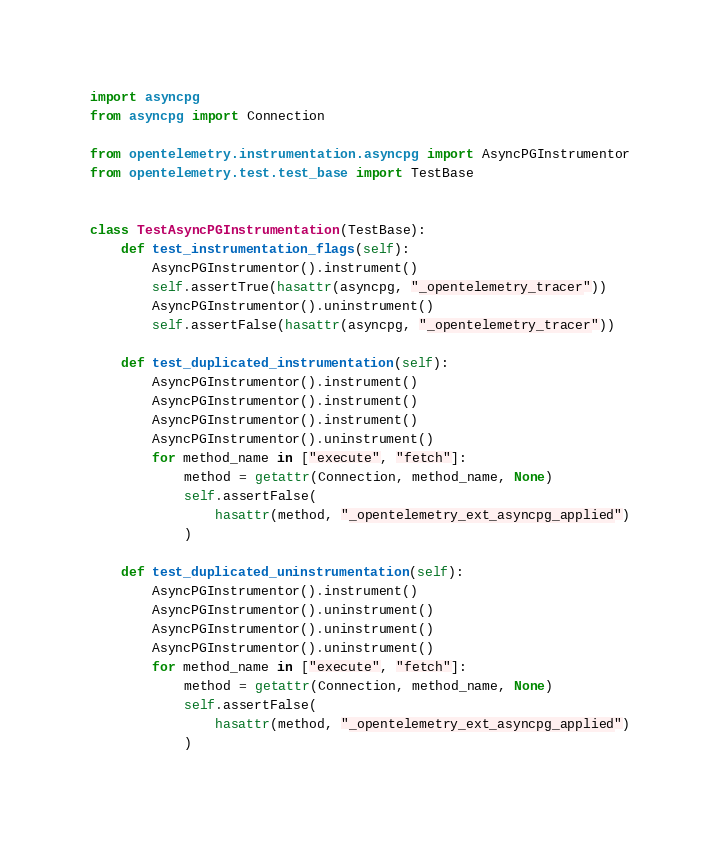Convert code to text. <code><loc_0><loc_0><loc_500><loc_500><_Python_>import asyncpg
from asyncpg import Connection

from opentelemetry.instrumentation.asyncpg import AsyncPGInstrumentor
from opentelemetry.test.test_base import TestBase


class TestAsyncPGInstrumentation(TestBase):
    def test_instrumentation_flags(self):
        AsyncPGInstrumentor().instrument()
        self.assertTrue(hasattr(asyncpg, "_opentelemetry_tracer"))
        AsyncPGInstrumentor().uninstrument()
        self.assertFalse(hasattr(asyncpg, "_opentelemetry_tracer"))

    def test_duplicated_instrumentation(self):
        AsyncPGInstrumentor().instrument()
        AsyncPGInstrumentor().instrument()
        AsyncPGInstrumentor().instrument()
        AsyncPGInstrumentor().uninstrument()
        for method_name in ["execute", "fetch"]:
            method = getattr(Connection, method_name, None)
            self.assertFalse(
                hasattr(method, "_opentelemetry_ext_asyncpg_applied")
            )

    def test_duplicated_uninstrumentation(self):
        AsyncPGInstrumentor().instrument()
        AsyncPGInstrumentor().uninstrument()
        AsyncPGInstrumentor().uninstrument()
        AsyncPGInstrumentor().uninstrument()
        for method_name in ["execute", "fetch"]:
            method = getattr(Connection, method_name, None)
            self.assertFalse(
                hasattr(method, "_opentelemetry_ext_asyncpg_applied")
            )
</code> 